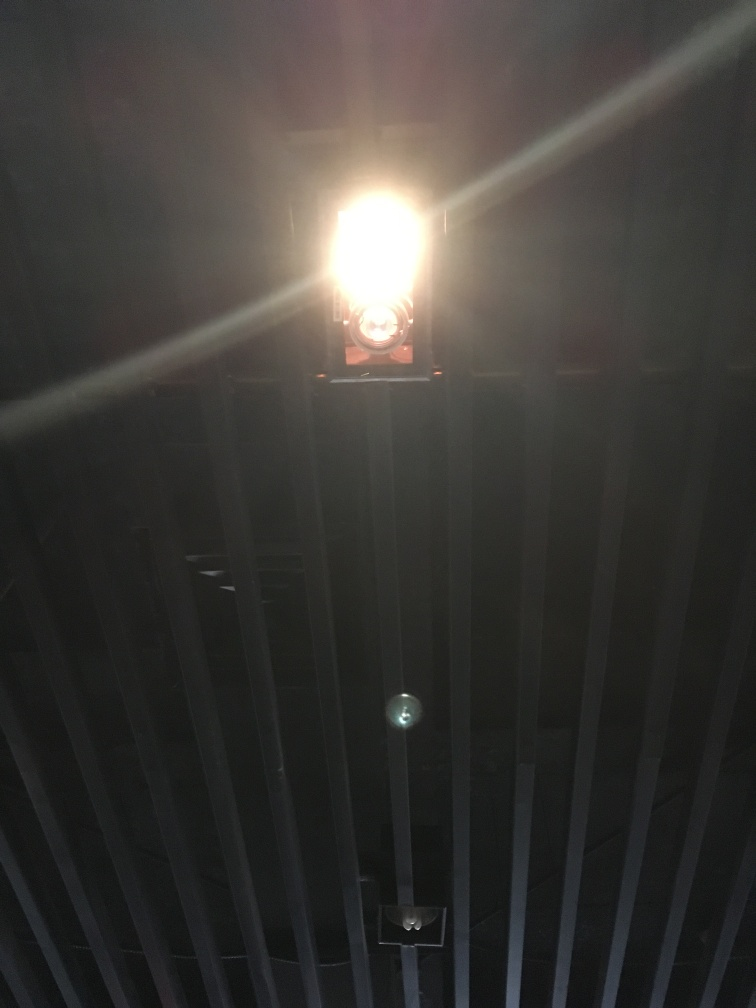How does the composition of this image relate to common photographic rules, such as the rule of thirds or leading lines? This image plays with the rule of thirds by positioning the brightest part of the image off-center, which naturally draws the viewer's eye. However, the bars can be seen as leading lines that guide the viewer's focus toward the light source. Though the image doesn't adhere strictly to conventional photographic rules, it uses these elements to create an interesting visual tension where the light is the dominant feature despite not being placed at a typical focal point. 